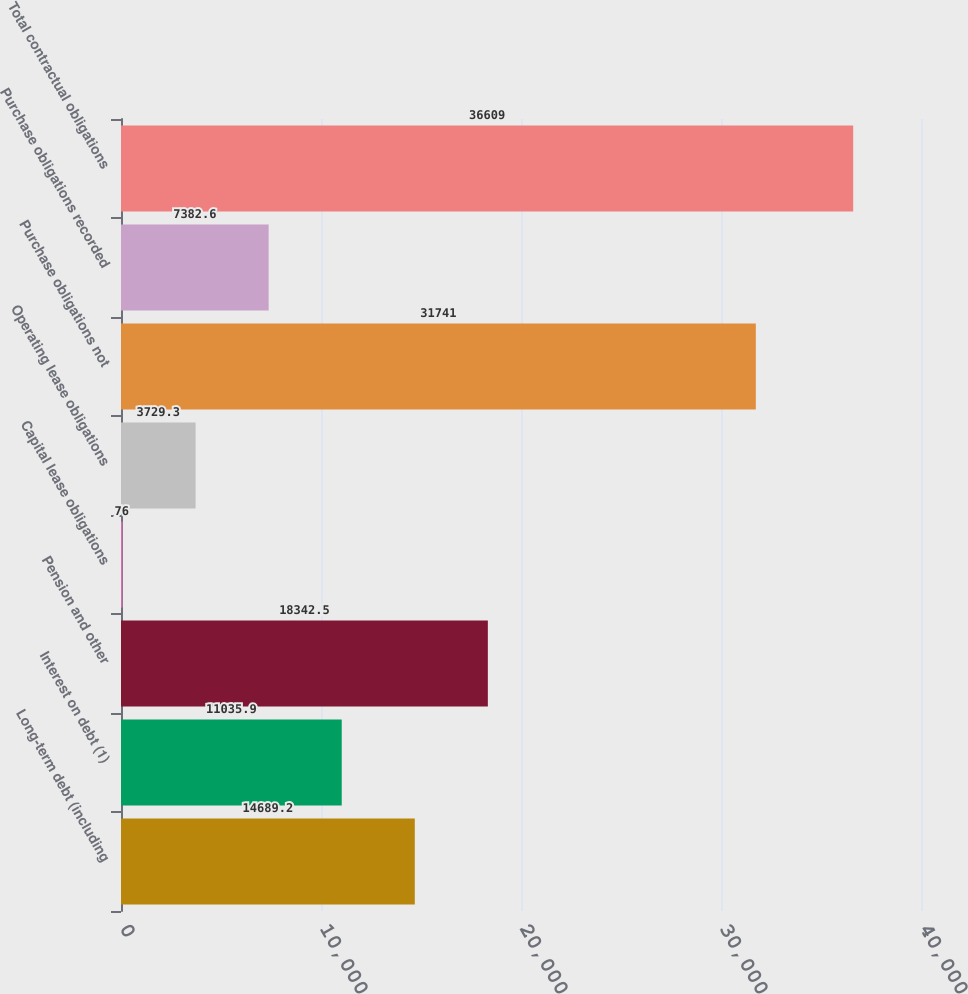Convert chart. <chart><loc_0><loc_0><loc_500><loc_500><bar_chart><fcel>Long-term debt (including<fcel>Interest on debt (1)<fcel>Pension and other<fcel>Capital lease obligations<fcel>Operating lease obligations<fcel>Purchase obligations not<fcel>Purchase obligations recorded<fcel>Total contractual obligations<nl><fcel>14689.2<fcel>11035.9<fcel>18342.5<fcel>76<fcel>3729.3<fcel>31741<fcel>7382.6<fcel>36609<nl></chart> 